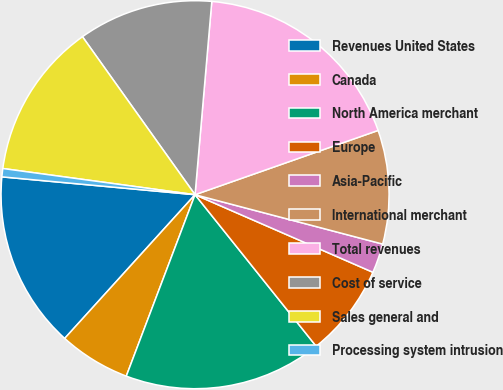Convert chart to OTSL. <chart><loc_0><loc_0><loc_500><loc_500><pie_chart><fcel>Revenues United States<fcel>Canada<fcel>North America merchant<fcel>Europe<fcel>Asia-Pacific<fcel>International merchant<fcel>Total revenues<fcel>Cost of service<fcel>Sales general and<fcel>Processing system intrusion<nl><fcel>14.74%<fcel>5.96%<fcel>16.5%<fcel>7.72%<fcel>2.45%<fcel>9.47%<fcel>18.25%<fcel>11.23%<fcel>12.99%<fcel>0.69%<nl></chart> 